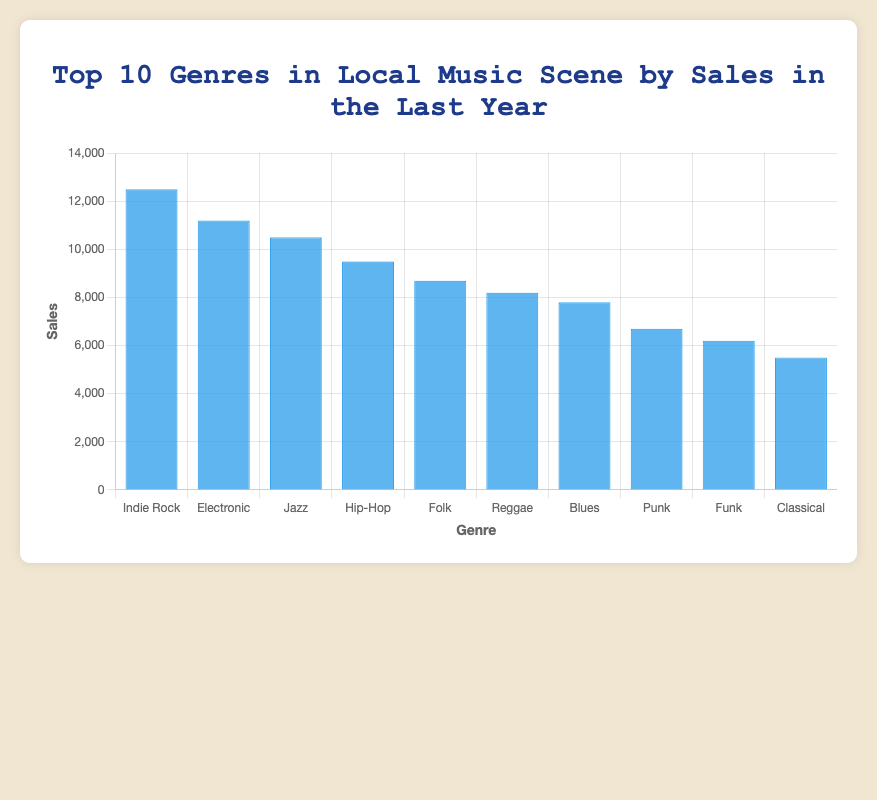Which genre recorded the highest sales in the last year? Looking at the bar chart, identify the highest bar on the chart. The genre corresponding to the highest bar is the one with the highest sales.
Answer: Indie Rock Which two genres have the closest sales figures? Compare the heights of the bars to find the two that are closest in height. Here, Indie Rock and Electronic have sales figures of 12500 and 11200, respectively, which are closest to each other.
Answer: Indie Rock and Electronic How much higher are Blues sales compared to Funk sales? Refer to the chart and find the sales for Blues (7800) and Funk (6200). Subtract the sales of Funk from Blues to determine the difference: 7800 - 6200 = 1600.
Answer: 1600 What is the combined sales figure for Jazz, Hip-Hop, and Folk genres? Find the sales for Jazz (10500), Hip-Hop (9500), and Folk (8700). Sum these figures: 10500 + 9500 + 8700 = 28700.
Answer: 28700 Which genre has the lowest sales? Look for the shortest bar on the chart, which represents the genre with the lowest sales. The Classical genre has the shortest bar and sales of 5500.
Answer: Classical What percentage of total sales does the Indie Rock genre represent? First, find the total sales by summing sales of all genres: 12500 + 11200 + 10500 + 9500 + 8700 + 8200 + 7800 + 6700 + 6200 + 5500 = 87100. Then, calculate the percentage: (12500 / 87100) * 100 ≈ 14.35%.
Answer: 14.35% Rank the genres from highest to lowest sales. Observe the heights of the bars and order them from tallest to shortest: Indie Rock, Electronic, Jazz, Hip-Hop, Folk, Reggae, Blues, Punk, Funk, Classical.
Answer: Indie Rock, Electronic, Jazz, Hip-Hop, Folk, Reggae, Blues, Punk, Funk, Classical What is the difference in sales between the top genre and the bottom genre? Identify the sales for the top genre, Indie Rock (12500), and the bottom genre, Classical (5500). Subtract the sales of Classical from Indie Rock: 12500 - 5500 = 7000.
Answer: 7000 If Classical sales doubled, where would it rank among the top 10 genres? Assuming Classical sales double: 5500 * 2 = 11000. Place 11000 in the current list of sales, noticing that it would fall between Electronic (11200) and Jazz (10500). It would rank 3rd, after Indie Rock and Electronic.
Answer: 3rd Which genre's sales would need to increase by 5000 to surpass Folk in sales? Calculate the sales that surpass Folk’s sales (8700) by adding 5000 to other genre figures. When comparing, Punk (6700 + 5000 = 11700), Reggae (8200 + 5000 = 13200), and others show, Funk (6200 + 5000 = 11200) would surpass Folk.
Answer: Funk 